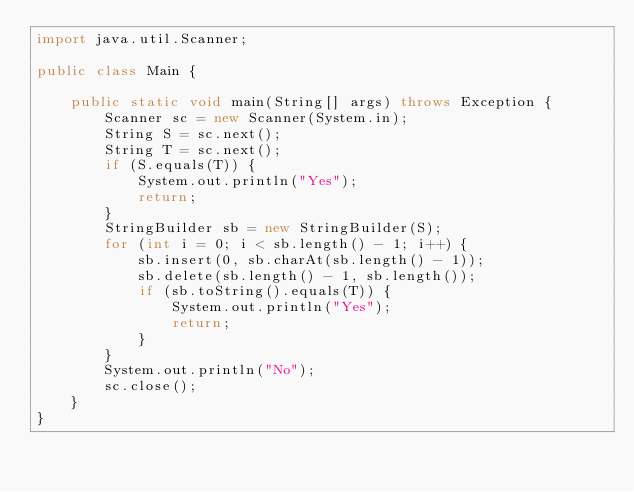<code> <loc_0><loc_0><loc_500><loc_500><_Java_>import java.util.Scanner;

public class Main {

	public static void main(String[] args) throws Exception {
		Scanner sc = new Scanner(System.in);
		String S = sc.next();
		String T = sc.next();
		if (S.equals(T)) {
			System.out.println("Yes");
			return;
		}
		StringBuilder sb = new StringBuilder(S);
		for (int i = 0; i < sb.length() - 1; i++) {
			sb.insert(0, sb.charAt(sb.length() - 1));
			sb.delete(sb.length() - 1, sb.length());
			if (sb.toString().equals(T)) {
				System.out.println("Yes");
				return;
			}
		}
		System.out.println("No");
		sc.close();
	}
}</code> 